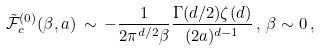<formula> <loc_0><loc_0><loc_500><loc_500>\tilde { \mathcal { F } } _ { c } ^ { ( 0 ) } ( \beta , a ) \, \sim \, - \frac { 1 } { 2 \pi ^ { d / 2 } \beta } \frac { \Gamma ( d / 2 ) \zeta ( d ) } { ( 2 a ) ^ { d - 1 } } \, , \, \beta \sim 0 \, ,</formula> 